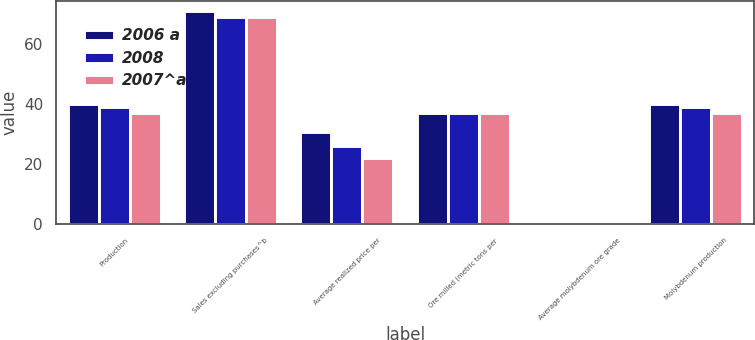Convert chart. <chart><loc_0><loc_0><loc_500><loc_500><stacked_bar_chart><ecel><fcel>Production<fcel>Sales excluding purchases^b<fcel>Average realized price per<fcel>Ore milled (metric tons per<fcel>Average molybdenum ore grade<fcel>Molybdenum production<nl><fcel>2006 a<fcel>40<fcel>71<fcel>30.55<fcel>37<fcel>0.23<fcel>40<nl><fcel>2008<fcel>39<fcel>69<fcel>25.87<fcel>37<fcel>0.23<fcel>39<nl><fcel>2007^a<fcel>37<fcel>69<fcel>21.87<fcel>37<fcel>0.23<fcel>37<nl></chart> 